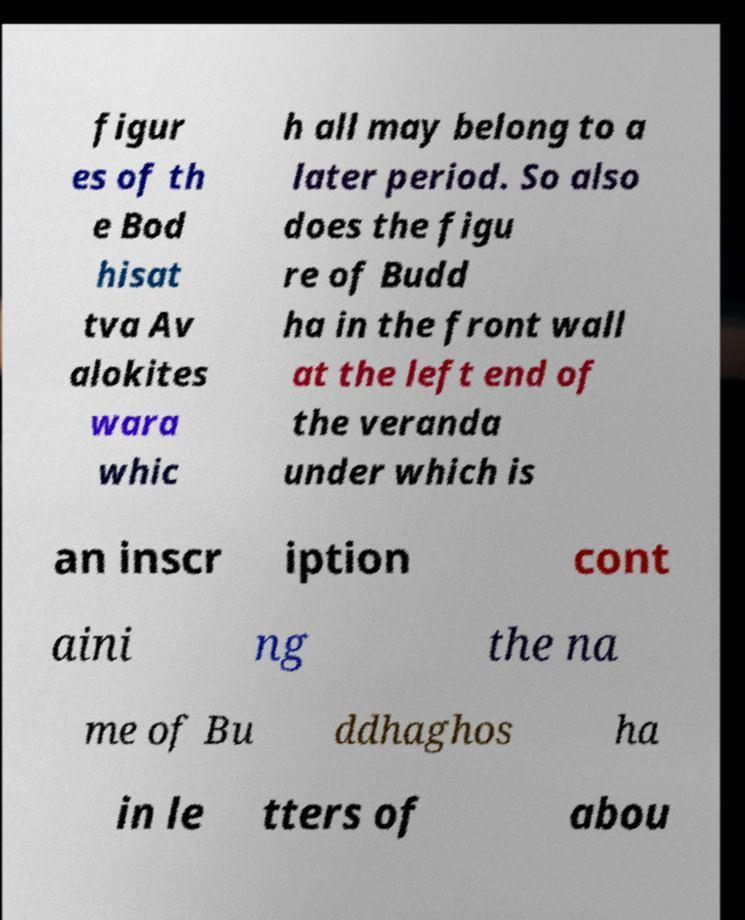Can you accurately transcribe the text from the provided image for me? figur es of th e Bod hisat tva Av alokites wara whic h all may belong to a later period. So also does the figu re of Budd ha in the front wall at the left end of the veranda under which is an inscr iption cont aini ng the na me of Bu ddhaghos ha in le tters of abou 